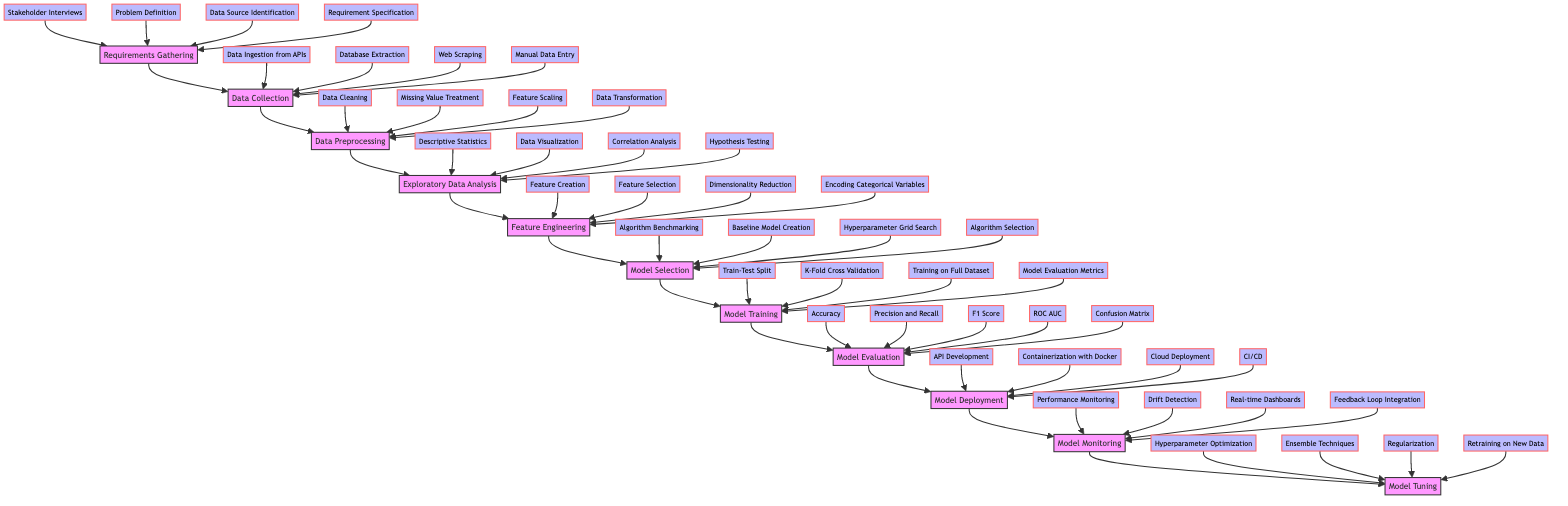What is the first stage in the development pipeline? The diagram indicates that the first stage is 'Requirements Gathering', as it is positioned at the bottom of the flowchart and has the initial arrow leading into it.
Answer: Requirements Gathering How many elements are associated with 'Model Evaluation'? In the diagram, 'Model Evaluation' has five elements listed: Accuracy, Precision and Recall, F1 Score, ROC AUC, Confusion Matrix. Thus, the total count is five.
Answer: 5 Which stage directly follows 'Data Preprocessing'? Reviewing the flow of the diagram, 'Exploratory Data Analysis' is the next stage that follows 'Data Preprocessing' as the arrow moves upward from one stage to the next.
Answer: Exploratory Data Analysis What elements are involved in 'Data Collection'? In the diagram, the elements listed for 'Data Collection' include: Data Ingestion from APIs, Database Extraction, Web Scraping, Manual Data Entry, thus covering all the processes involved in this stage.
Answer: Data Ingestion from APIs, Database Extraction, Web Scraping, Manual Data Entry What is the last stage in the development pipeline? The topmost stage in the flowchart, which indicates the final part of the development pipeline, is 'Model Tuning'. This is confirmed by observing the upward flow leading to the final node.
Answer: Model Tuning How many stages are there in total from 'Requirements Gathering' to 'Model Tuning'? Counting all the stages shown in the diagram from the bottom stage 'Requirements Gathering' to the top stage 'Model Tuning' yields a total of eleven stages.
Answer: 11 Which two stages are directly linked by an arrow? The diagram explicitly shows arrows connecting various stages. For instance, 'Exploratory Data Analysis' and 'Feature Engineering' are directly linked by an upward arrow, indicating a direct relationship.
Answer: Exploratory Data Analysis and Feature Engineering What processes are included under 'Model Tuning'? The listed processes under 'Model Tuning' in the diagram include: Hyperparameter Optimization, Ensemble Techniques, Regularization, and Retraining on New Data. This shows all the key components of this final stage.
Answer: Hyperparameter Optimization, Ensemble Techniques, Regularization, Retraining on New Data 